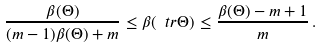Convert formula to latex. <formula><loc_0><loc_0><loc_500><loc_500>\frac { \beta ( \Theta ) } { ( m - 1 ) \beta ( \Theta ) + m } \leq \beta ( \ t r \Theta ) \leq \frac { \beta ( \Theta ) - m + 1 } { m } \, .</formula> 